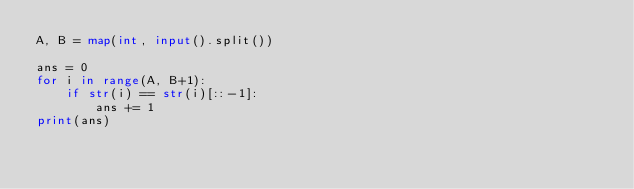Convert code to text. <code><loc_0><loc_0><loc_500><loc_500><_Python_>A, B = map(int, input().split())

ans = 0
for i in range(A, B+1):
    if str(i) == str(i)[::-1]:
        ans += 1
print(ans)</code> 